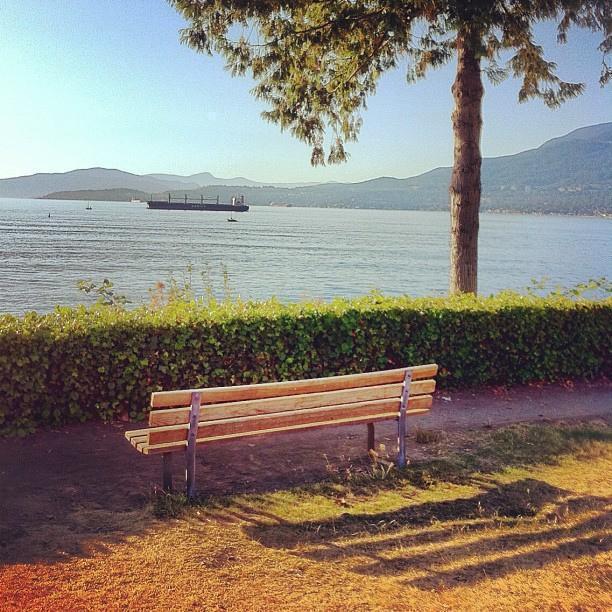What is casted on the ground behind the bench?
Pick the right solution, then justify: 'Answer: answer
Rationale: rationale.'
Options: Doubt, shadow, mirror image, hole. Answer: shadow.
Rationale: It is sunny. the bench is blocking some of the sunlight, so there are dark areas on the ground. 